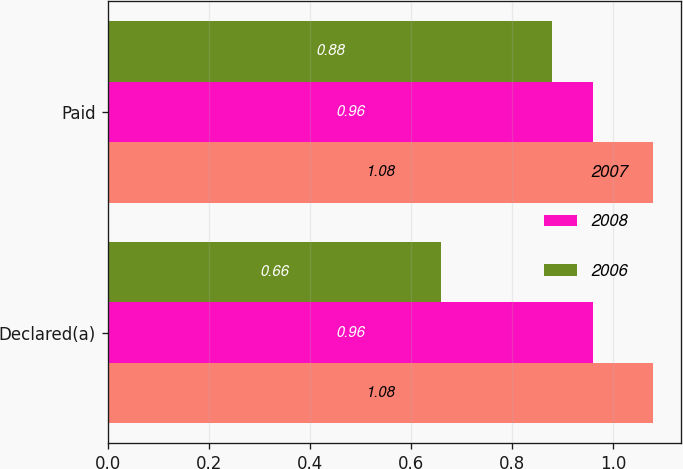<chart> <loc_0><loc_0><loc_500><loc_500><stacked_bar_chart><ecel><fcel>Declared(a)<fcel>Paid<nl><fcel>2007<fcel>1.08<fcel>1.08<nl><fcel>2008<fcel>0.96<fcel>0.96<nl><fcel>2006<fcel>0.66<fcel>0.88<nl></chart> 